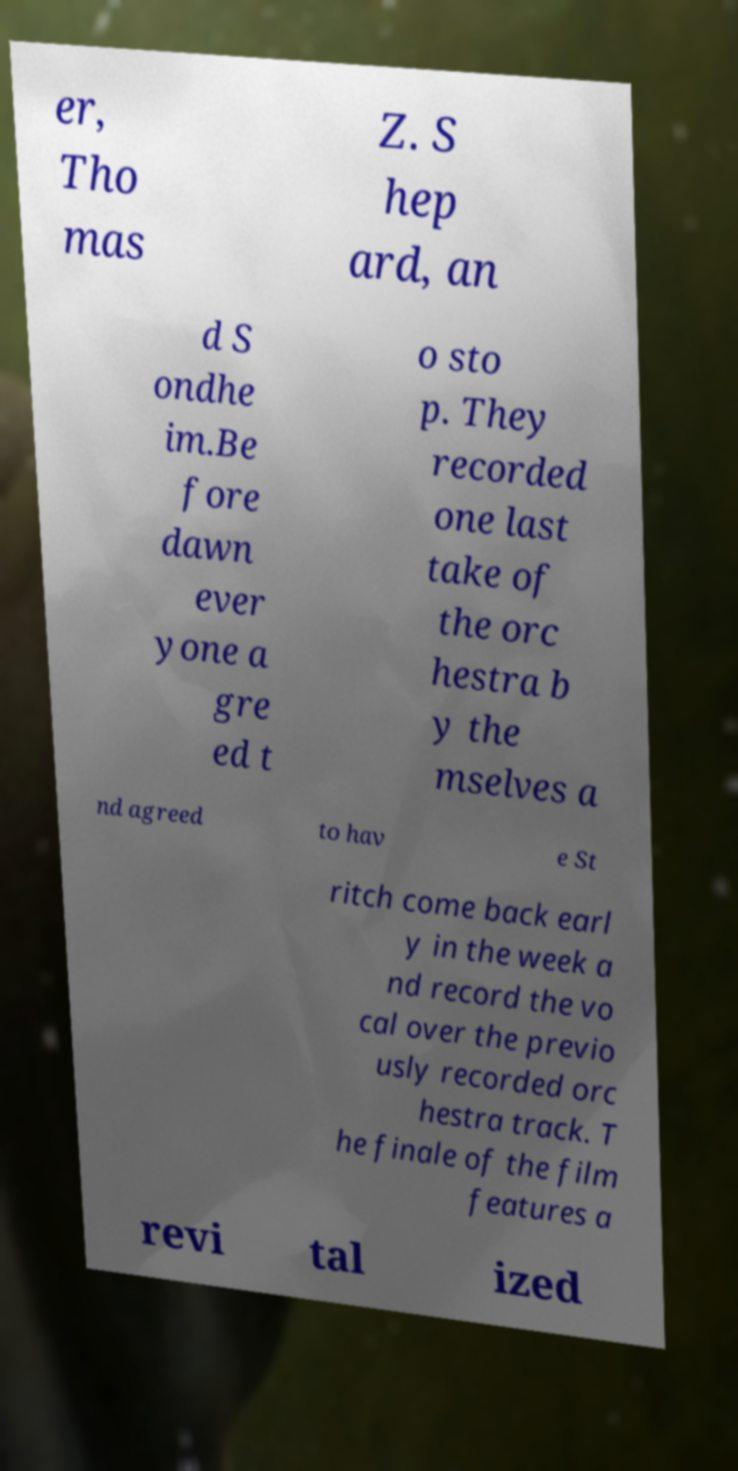Can you accurately transcribe the text from the provided image for me? er, Tho mas Z. S hep ard, an d S ondhe im.Be fore dawn ever yone a gre ed t o sto p. They recorded one last take of the orc hestra b y the mselves a nd agreed to hav e St ritch come back earl y in the week a nd record the vo cal over the previo usly recorded orc hestra track. T he finale of the film features a revi tal ized 